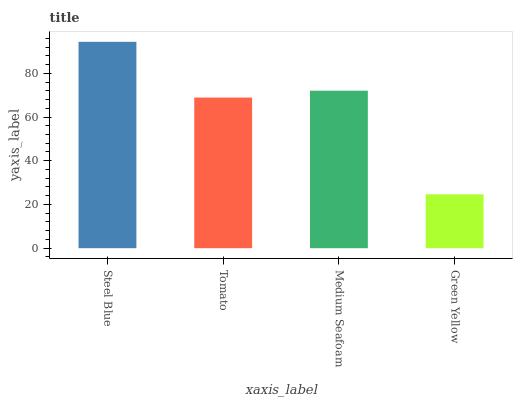Is Green Yellow the minimum?
Answer yes or no. Yes. Is Steel Blue the maximum?
Answer yes or no. Yes. Is Tomato the minimum?
Answer yes or no. No. Is Tomato the maximum?
Answer yes or no. No. Is Steel Blue greater than Tomato?
Answer yes or no. Yes. Is Tomato less than Steel Blue?
Answer yes or no. Yes. Is Tomato greater than Steel Blue?
Answer yes or no. No. Is Steel Blue less than Tomato?
Answer yes or no. No. Is Medium Seafoam the high median?
Answer yes or no. Yes. Is Tomato the low median?
Answer yes or no. Yes. Is Tomato the high median?
Answer yes or no. No. Is Green Yellow the low median?
Answer yes or no. No. 